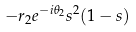Convert formula to latex. <formula><loc_0><loc_0><loc_500><loc_500>- r _ { 2 } e ^ { - i \theta _ { 2 } } s ^ { 2 } ( 1 - s )</formula> 